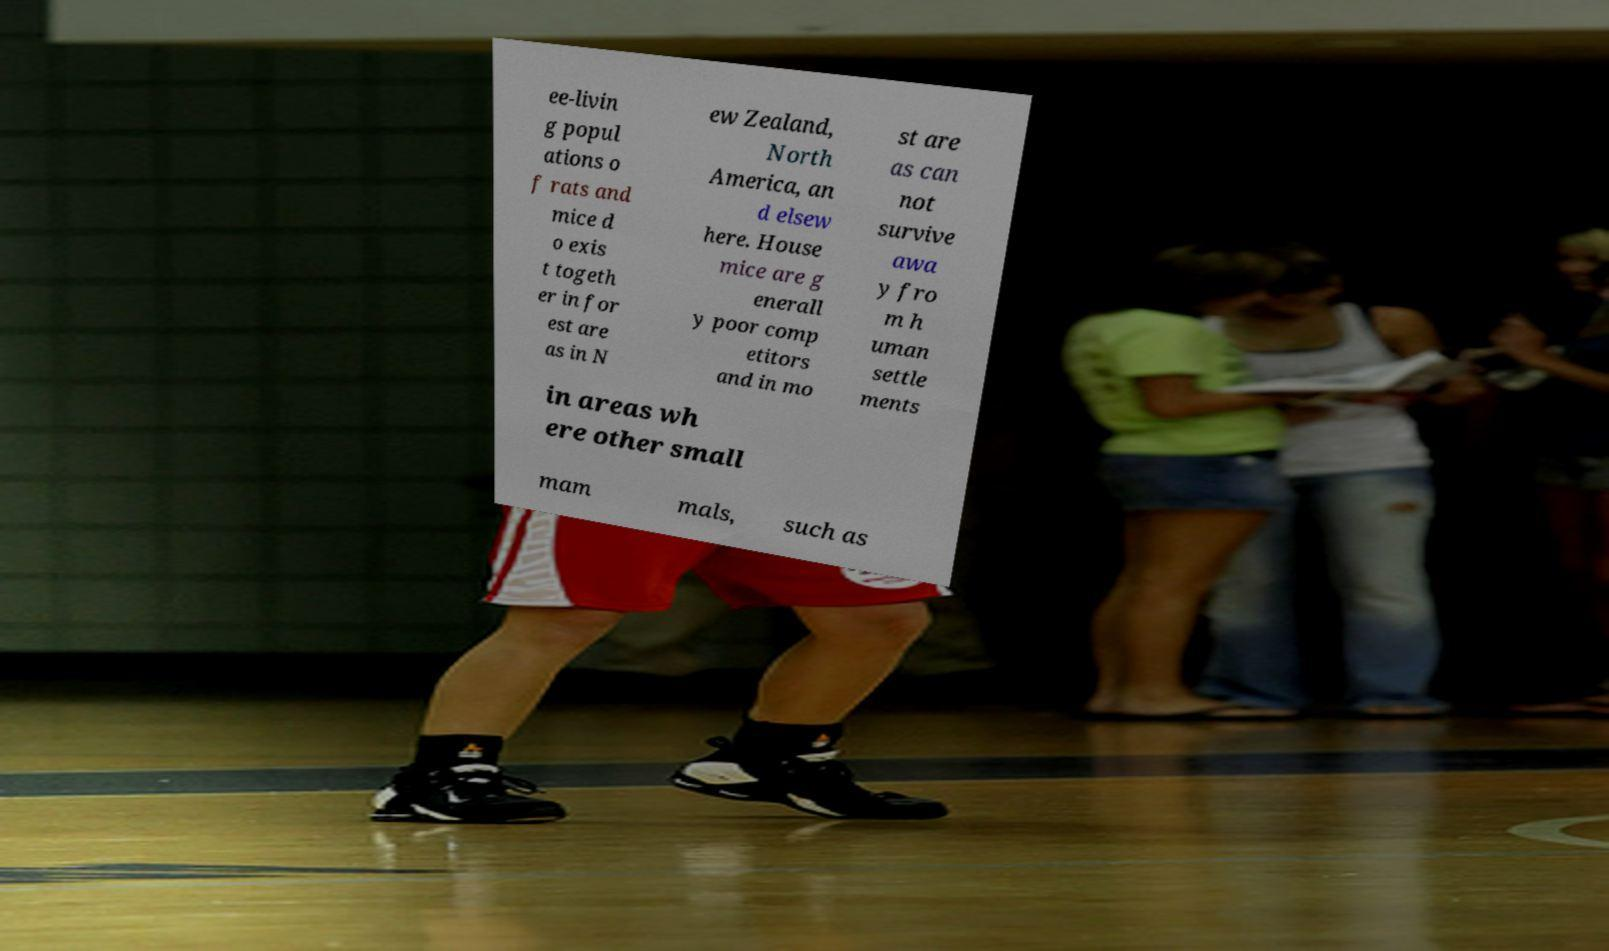There's text embedded in this image that I need extracted. Can you transcribe it verbatim? ee-livin g popul ations o f rats and mice d o exis t togeth er in for est are as in N ew Zealand, North America, an d elsew here. House mice are g enerall y poor comp etitors and in mo st are as can not survive awa y fro m h uman settle ments in areas wh ere other small mam mals, such as 